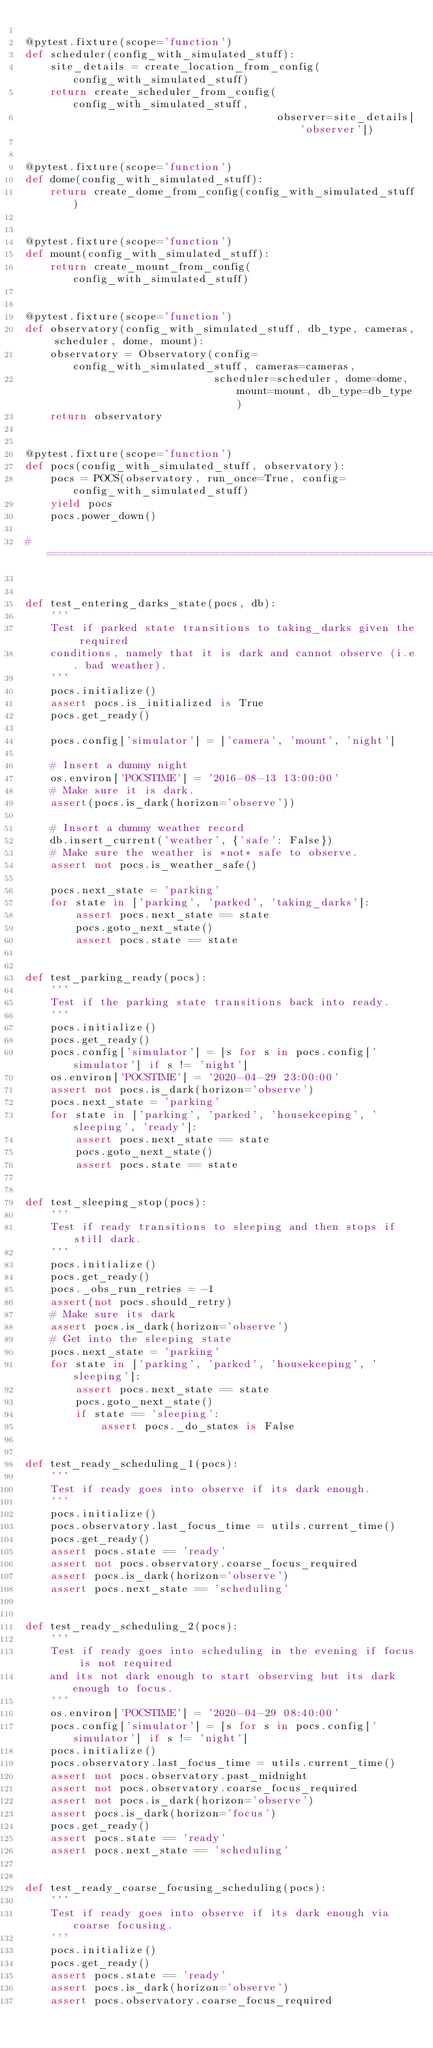Convert code to text. <code><loc_0><loc_0><loc_500><loc_500><_Python_>
@pytest.fixture(scope='function')
def scheduler(config_with_simulated_stuff):
    site_details = create_location_from_config(config_with_simulated_stuff)
    return create_scheduler_from_config(config_with_simulated_stuff,
                                        observer=site_details['observer'])


@pytest.fixture(scope='function')
def dome(config_with_simulated_stuff):
    return create_dome_from_config(config_with_simulated_stuff)


@pytest.fixture(scope='function')
def mount(config_with_simulated_stuff):
    return create_mount_from_config(config_with_simulated_stuff)


@pytest.fixture(scope='function')
def observatory(config_with_simulated_stuff, db_type, cameras, scheduler, dome, mount):
    observatory = Observatory(config=config_with_simulated_stuff, cameras=cameras,
                              scheduler=scheduler, dome=dome, mount=mount, db_type=db_type)
    return observatory


@pytest.fixture(scope='function')
def pocs(config_with_simulated_stuff, observatory):
    pocs = POCS(observatory, run_once=True, config=config_with_simulated_stuff)
    yield pocs
    pocs.power_down()

# ==============================================================================


def test_entering_darks_state(pocs, db):
    '''
    Test if parked state transitions to taking_darks given the required
    conditions, namely that it is dark and cannot observe (i.e. bad weather).
    '''
    pocs.initialize()
    assert pocs.is_initialized is True
    pocs.get_ready()

    pocs.config['simulator'] = ['camera', 'mount', 'night']

    # Insert a dummy night
    os.environ['POCSTIME'] = '2016-08-13 13:00:00'
    # Make sure it is dark.
    assert(pocs.is_dark(horizon='observe'))

    # Insert a dummy weather record
    db.insert_current('weather', {'safe': False})
    # Make sure the weather is *not* safe to observe.
    assert not pocs.is_weather_safe()

    pocs.next_state = 'parking'
    for state in ['parking', 'parked', 'taking_darks']:
        assert pocs.next_state == state
        pocs.goto_next_state()
        assert pocs.state == state


def test_parking_ready(pocs):
    '''
    Test if the parking state transitions back into ready.
    '''
    pocs.initialize()
    pocs.get_ready()
    pocs.config['simulator'] = [s for s in pocs.config['simulator'] if s != 'night']
    os.environ['POCSTIME'] = '2020-04-29 23:00:00'
    assert not pocs.is_dark(horizon='observe')
    pocs.next_state = 'parking'
    for state in ['parking', 'parked', 'housekeeping', 'sleeping', 'ready']:
        assert pocs.next_state == state
        pocs.goto_next_state()
        assert pocs.state == state


def test_sleeping_stop(pocs):
    '''
    Test if ready transitions to sleeping and then stops if still dark.
    '''
    pocs.initialize()
    pocs.get_ready()
    pocs._obs_run_retries = -1
    assert(not pocs.should_retry)
    # Make sure its dark
    assert pocs.is_dark(horizon='observe')
    # Get into the sleeping state
    pocs.next_state = 'parking'
    for state in ['parking', 'parked', 'housekeeping', 'sleeping']:
        assert pocs.next_state == state
        pocs.goto_next_state()
        if state == 'sleeping':
            assert pocs._do_states is False


def test_ready_scheduling_1(pocs):
    '''
    Test if ready goes into observe if its dark enough.
    '''
    pocs.initialize()
    pocs.observatory.last_focus_time = utils.current_time()
    pocs.get_ready()
    assert pocs.state == 'ready'
    assert not pocs.observatory.coarse_focus_required
    assert pocs.is_dark(horizon='observe')
    assert pocs.next_state == 'scheduling'


def test_ready_scheduling_2(pocs):
    '''
    Test if ready goes into scheduling in the evening if focus is not required
    and its not dark enough to start observing but its dark enough to focus.
    '''
    os.environ['POCSTIME'] = '2020-04-29 08:40:00'
    pocs.config['simulator'] = [s for s in pocs.config['simulator'] if s != 'night']
    pocs.initialize()
    pocs.observatory.last_focus_time = utils.current_time()
    assert not pocs.observatory.past_midnight
    assert not pocs.observatory.coarse_focus_required
    assert not pocs.is_dark(horizon='observe')
    assert pocs.is_dark(horizon='focus')
    pocs.get_ready()
    assert pocs.state == 'ready'
    assert pocs.next_state == 'scheduling'


def test_ready_coarse_focusing_scheduling(pocs):
    '''
    Test if ready goes into observe if its dark enough via coarse focusing.
    '''
    pocs.initialize()
    pocs.get_ready()
    assert pocs.state == 'ready'
    assert pocs.is_dark(horizon='observe')
    assert pocs.observatory.coarse_focus_required</code> 